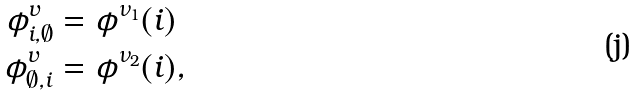<formula> <loc_0><loc_0><loc_500><loc_500>\phi ^ { v } _ { i , \emptyset } & = \phi ^ { \nu _ { 1 } } ( i ) \\ \phi ^ { v } _ { \emptyset , i } & = \phi ^ { \nu _ { 2 } } ( i ) ,</formula> 